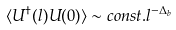<formula> <loc_0><loc_0><loc_500><loc_500>\langle U ^ { \dagger } ( l ) U ( 0 ) \rangle \sim c o n s t . l ^ { - \Delta _ { b } }</formula> 